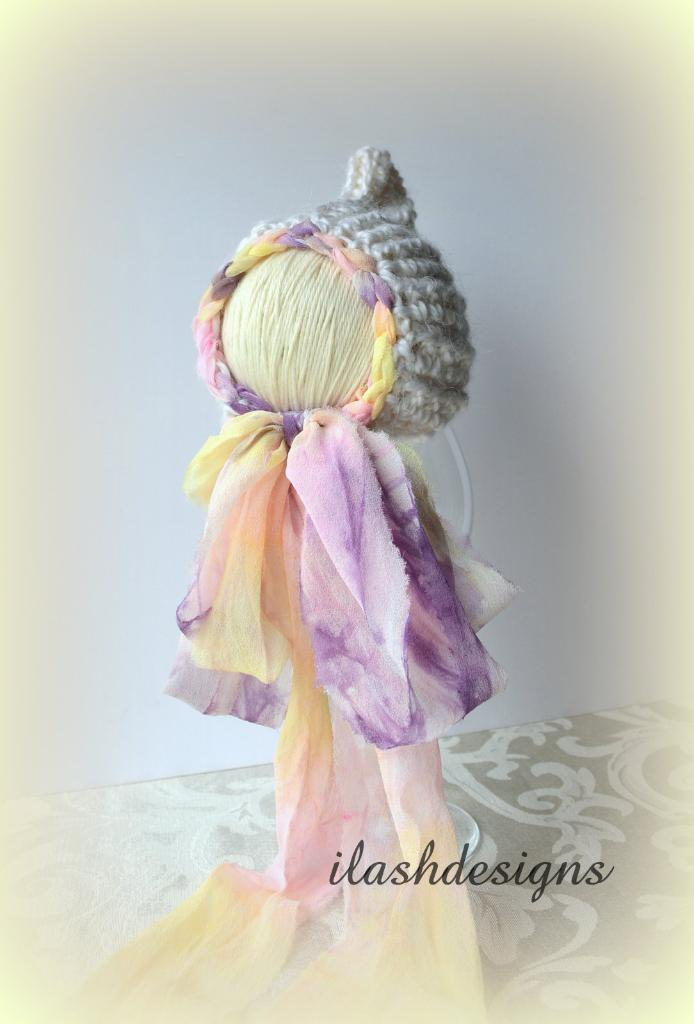What is the main subject of the image? The main subject of the image is a handicraft made with threads and clothes. Are there any distinguishing features on the handicraft? Yes, there is a watermark on the handicraft. What can be seen in the background of the image? There is a wall in the background of the image. What type of advice is given in the bedroom in the image? There is no bedroom present in the image, and therefore no advice can be given. What wish is granted by the handicraft in the image? The image does not depict a wish-granting handicraft, and no wishes are granted. 